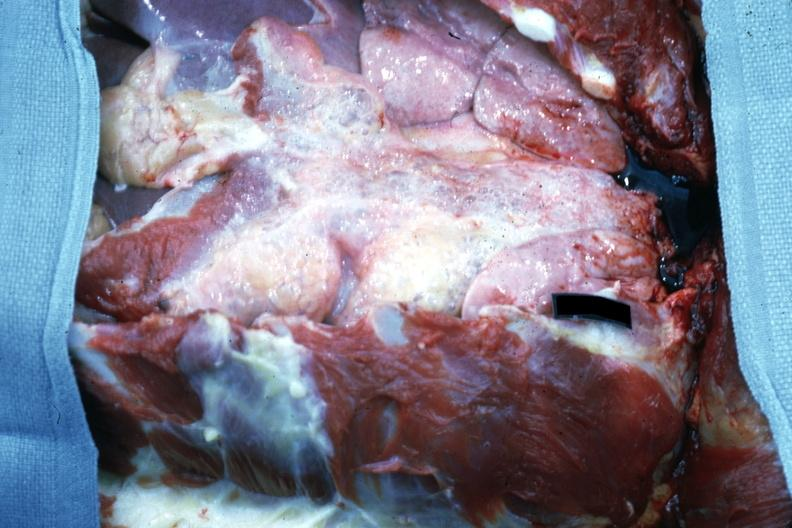what is present?
Answer the question using a single word or phrase. Thorax 